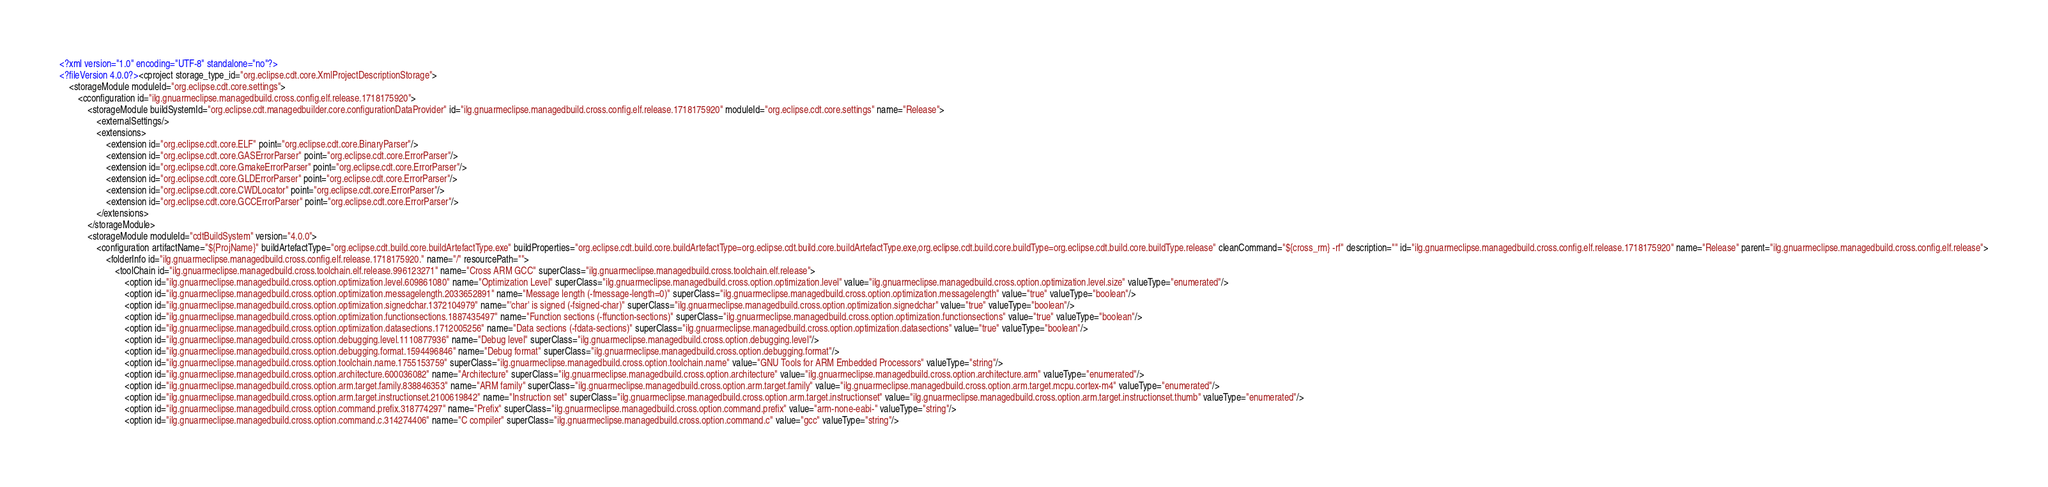Convert code to text. <code><loc_0><loc_0><loc_500><loc_500><_XML_><?xml version="1.0" encoding="UTF-8" standalone="no"?>
<?fileVersion 4.0.0?><cproject storage_type_id="org.eclipse.cdt.core.XmlProjectDescriptionStorage">
	<storageModule moduleId="org.eclipse.cdt.core.settings">
		<cconfiguration id="ilg.gnuarmeclipse.managedbuild.cross.config.elf.release.1718175920">
			<storageModule buildSystemId="org.eclipse.cdt.managedbuilder.core.configurationDataProvider" id="ilg.gnuarmeclipse.managedbuild.cross.config.elf.release.1718175920" moduleId="org.eclipse.cdt.core.settings" name="Release">
				<externalSettings/>
				<extensions>
					<extension id="org.eclipse.cdt.core.ELF" point="org.eclipse.cdt.core.BinaryParser"/>
					<extension id="org.eclipse.cdt.core.GASErrorParser" point="org.eclipse.cdt.core.ErrorParser"/>
					<extension id="org.eclipse.cdt.core.GmakeErrorParser" point="org.eclipse.cdt.core.ErrorParser"/>
					<extension id="org.eclipse.cdt.core.GLDErrorParser" point="org.eclipse.cdt.core.ErrorParser"/>
					<extension id="org.eclipse.cdt.core.CWDLocator" point="org.eclipse.cdt.core.ErrorParser"/>
					<extension id="org.eclipse.cdt.core.GCCErrorParser" point="org.eclipse.cdt.core.ErrorParser"/>
				</extensions>
			</storageModule>
			<storageModule moduleId="cdtBuildSystem" version="4.0.0">
				<configuration artifactName="${ProjName}" buildArtefactType="org.eclipse.cdt.build.core.buildArtefactType.exe" buildProperties="org.eclipse.cdt.build.core.buildArtefactType=org.eclipse.cdt.build.core.buildArtefactType.exe,org.eclipse.cdt.build.core.buildType=org.eclipse.cdt.build.core.buildType.release" cleanCommand="${cross_rm} -rf" description="" id="ilg.gnuarmeclipse.managedbuild.cross.config.elf.release.1718175920" name="Release" parent="ilg.gnuarmeclipse.managedbuild.cross.config.elf.release">
					<folderInfo id="ilg.gnuarmeclipse.managedbuild.cross.config.elf.release.1718175920." name="/" resourcePath="">
						<toolChain id="ilg.gnuarmeclipse.managedbuild.cross.toolchain.elf.release.996123271" name="Cross ARM GCC" superClass="ilg.gnuarmeclipse.managedbuild.cross.toolchain.elf.release">
							<option id="ilg.gnuarmeclipse.managedbuild.cross.option.optimization.level.609861080" name="Optimization Level" superClass="ilg.gnuarmeclipse.managedbuild.cross.option.optimization.level" value="ilg.gnuarmeclipse.managedbuild.cross.option.optimization.level.size" valueType="enumerated"/>
							<option id="ilg.gnuarmeclipse.managedbuild.cross.option.optimization.messagelength.2033652891" name="Message length (-fmessage-length=0)" superClass="ilg.gnuarmeclipse.managedbuild.cross.option.optimization.messagelength" value="true" valueType="boolean"/>
							<option id="ilg.gnuarmeclipse.managedbuild.cross.option.optimization.signedchar.1372104979" name="'char' is signed (-fsigned-char)" superClass="ilg.gnuarmeclipse.managedbuild.cross.option.optimization.signedchar" value="true" valueType="boolean"/>
							<option id="ilg.gnuarmeclipse.managedbuild.cross.option.optimization.functionsections.1887435497" name="Function sections (-ffunction-sections)" superClass="ilg.gnuarmeclipse.managedbuild.cross.option.optimization.functionsections" value="true" valueType="boolean"/>
							<option id="ilg.gnuarmeclipse.managedbuild.cross.option.optimization.datasections.1712005256" name="Data sections (-fdata-sections)" superClass="ilg.gnuarmeclipse.managedbuild.cross.option.optimization.datasections" value="true" valueType="boolean"/>
							<option id="ilg.gnuarmeclipse.managedbuild.cross.option.debugging.level.1110877936" name="Debug level" superClass="ilg.gnuarmeclipse.managedbuild.cross.option.debugging.level"/>
							<option id="ilg.gnuarmeclipse.managedbuild.cross.option.debugging.format.1594496846" name="Debug format" superClass="ilg.gnuarmeclipse.managedbuild.cross.option.debugging.format"/>
							<option id="ilg.gnuarmeclipse.managedbuild.cross.option.toolchain.name.1755153759" superClass="ilg.gnuarmeclipse.managedbuild.cross.option.toolchain.name" value="GNU Tools for ARM Embedded Processors" valueType="string"/>
							<option id="ilg.gnuarmeclipse.managedbuild.cross.option.architecture.600036082" name="Architecture" superClass="ilg.gnuarmeclipse.managedbuild.cross.option.architecture" value="ilg.gnuarmeclipse.managedbuild.cross.option.architecture.arm" valueType="enumerated"/>
							<option id="ilg.gnuarmeclipse.managedbuild.cross.option.arm.target.family.838846353" name="ARM family" superClass="ilg.gnuarmeclipse.managedbuild.cross.option.arm.target.family" value="ilg.gnuarmeclipse.managedbuild.cross.option.arm.target.mcpu.cortex-m4" valueType="enumerated"/>
							<option id="ilg.gnuarmeclipse.managedbuild.cross.option.arm.target.instructionset.2100619842" name="Instruction set" superClass="ilg.gnuarmeclipse.managedbuild.cross.option.arm.target.instructionset" value="ilg.gnuarmeclipse.managedbuild.cross.option.arm.target.instructionset.thumb" valueType="enumerated"/>
							<option id="ilg.gnuarmeclipse.managedbuild.cross.option.command.prefix.318774297" name="Prefix" superClass="ilg.gnuarmeclipse.managedbuild.cross.option.command.prefix" value="arm-none-eabi-" valueType="string"/>
							<option id="ilg.gnuarmeclipse.managedbuild.cross.option.command.c.314274406" name="C compiler" superClass="ilg.gnuarmeclipse.managedbuild.cross.option.command.c" value="gcc" valueType="string"/></code> 